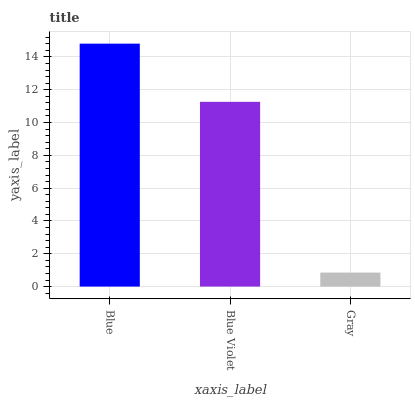Is Gray the minimum?
Answer yes or no. Yes. Is Blue the maximum?
Answer yes or no. Yes. Is Blue Violet the minimum?
Answer yes or no. No. Is Blue Violet the maximum?
Answer yes or no. No. Is Blue greater than Blue Violet?
Answer yes or no. Yes. Is Blue Violet less than Blue?
Answer yes or no. Yes. Is Blue Violet greater than Blue?
Answer yes or no. No. Is Blue less than Blue Violet?
Answer yes or no. No. Is Blue Violet the high median?
Answer yes or no. Yes. Is Blue Violet the low median?
Answer yes or no. Yes. Is Blue the high median?
Answer yes or no. No. Is Gray the low median?
Answer yes or no. No. 